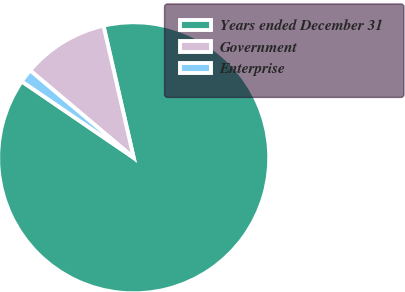<chart> <loc_0><loc_0><loc_500><loc_500><pie_chart><fcel>Years ended December 31<fcel>Government<fcel>Enterprise<nl><fcel>88.11%<fcel>10.27%<fcel>1.62%<nl></chart> 